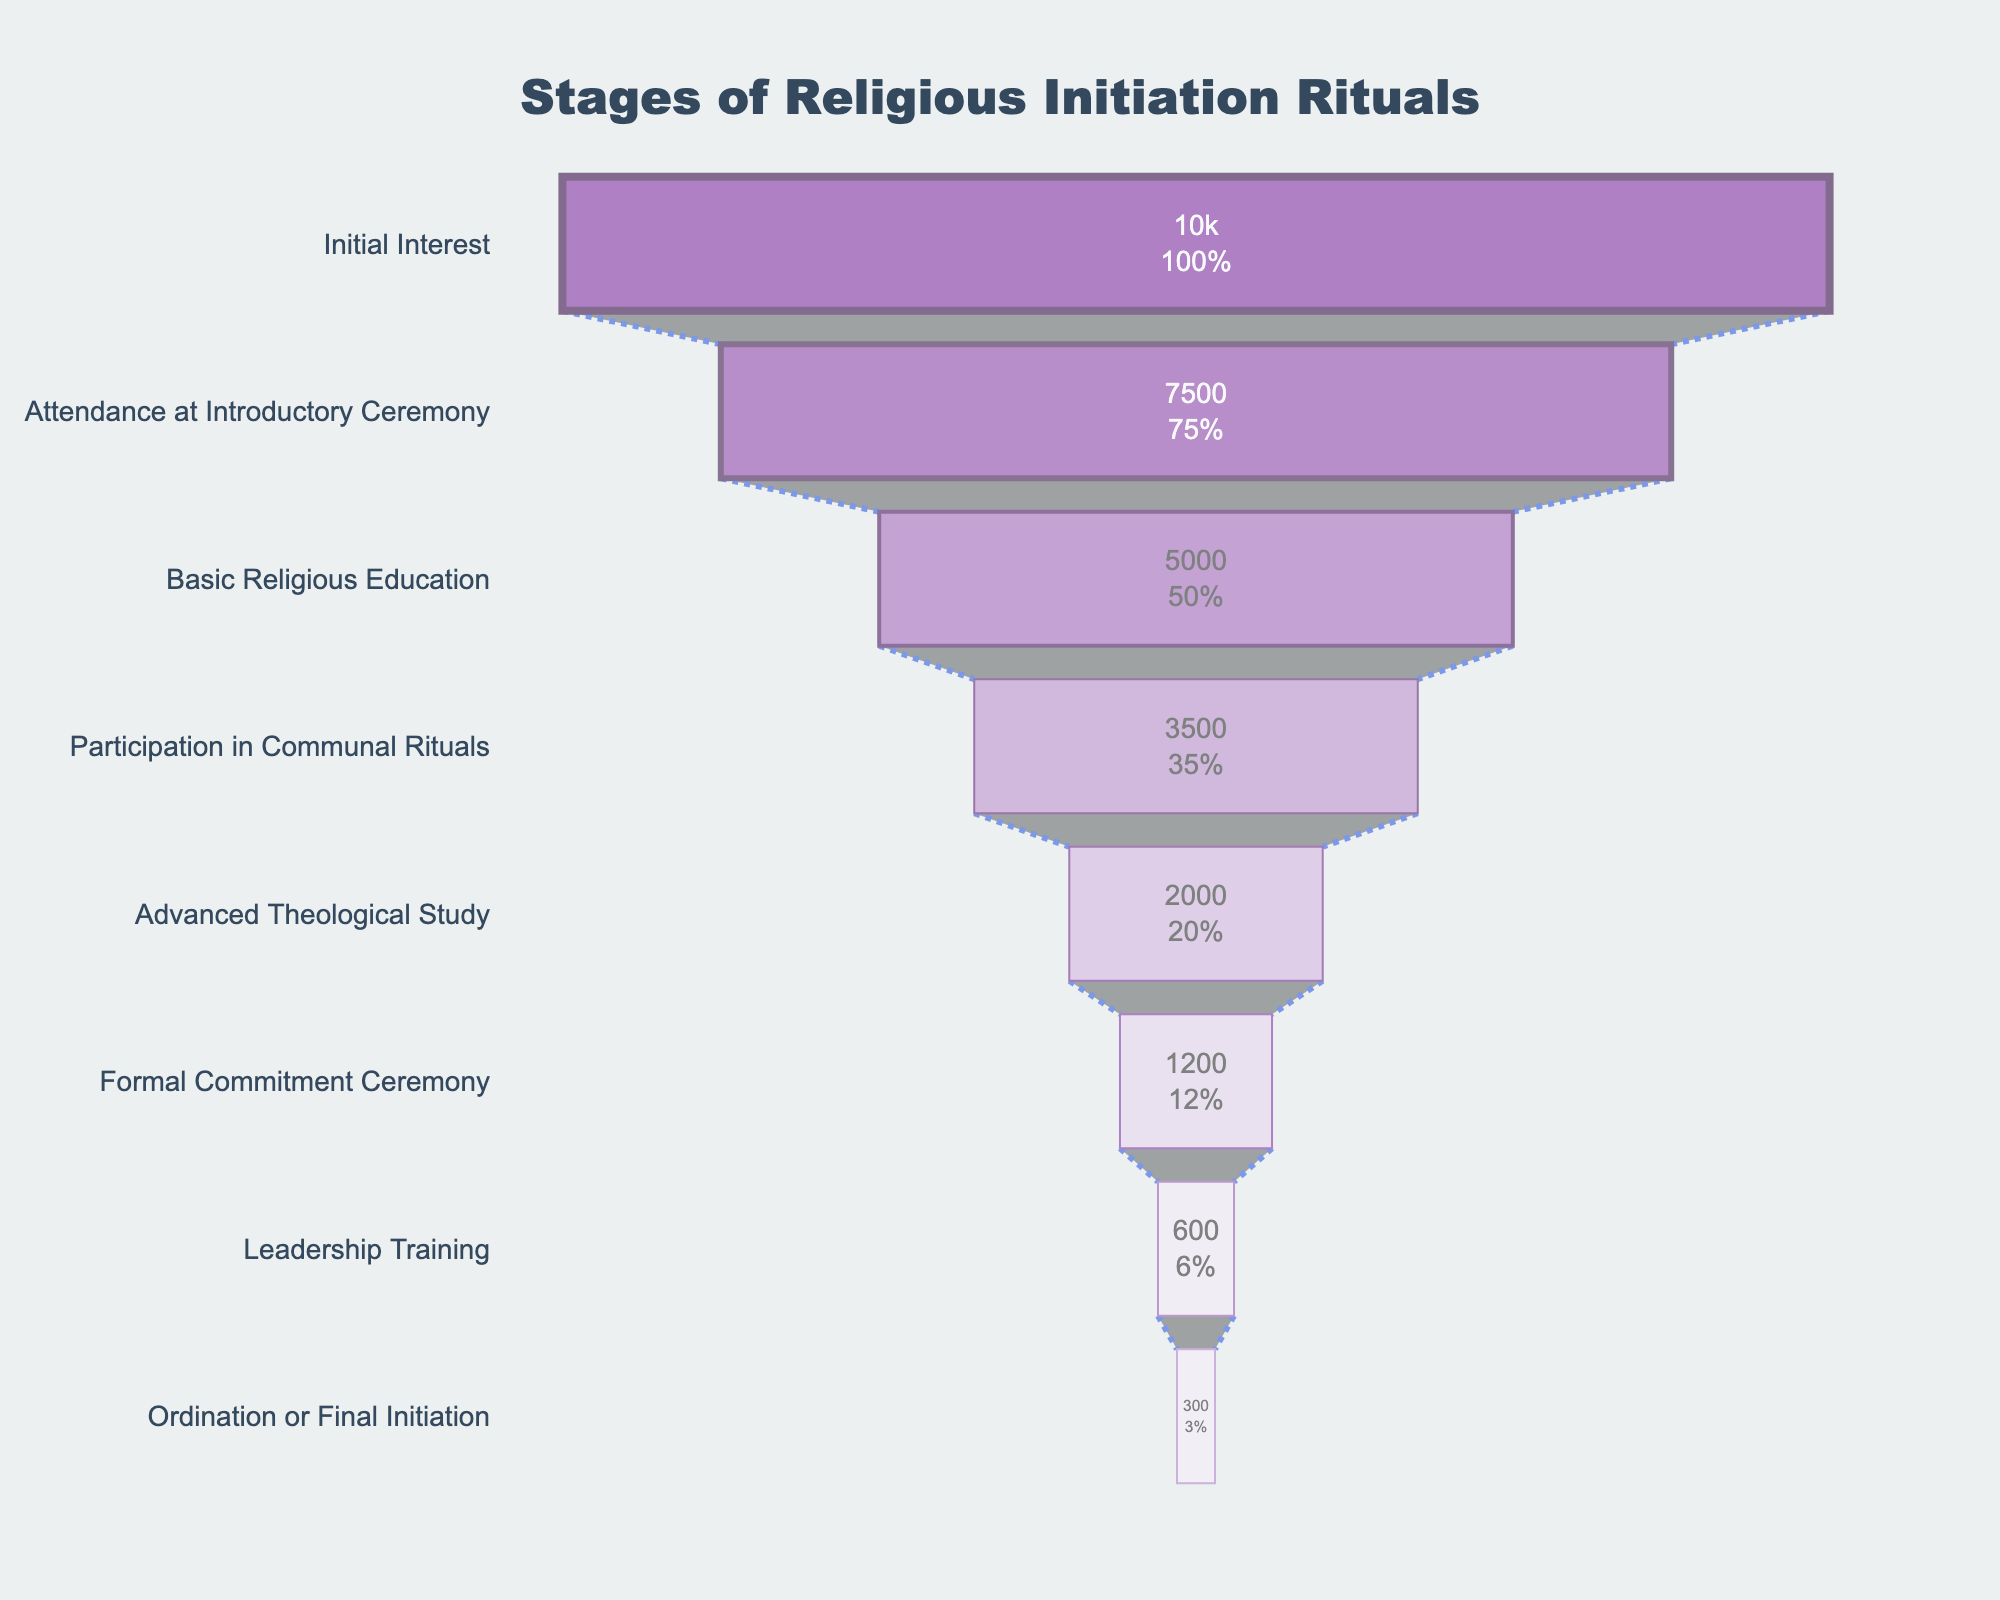What is the title of the funnel chart? The title of the funnel chart is always located at the top, centered. By looking at the top of the figure, one can read the title text.
Answer: Stages of Religious Initiation Rituals How many participants start with an initial interest? The funnel chart lists each stage along with the number of participants. At the top of the funnel, the number associated with "Initial Interest" is shown.
Answer: 10000 What percentage of participants engage in basic religious education compared to those who show initial interest? The chart provides percentages for each stage. For "Basic Religious Education," the percentage is shown on the bar starting from "Initial Interest."
Answer: 50% How many participants proceed from the Attendance at Introductory Ceremony to Basic Religious Education? Subtract the number of participants in "Basic Religious Education" from those in "Attendance at Introductory Ceremony": 7500 - 5000.
Answer: 2500 Which stage witnesses the highest dropout rate? By observing the drop in participant numbers from one stage to another, the highest dropout can be identified. The largest numerical gap between consecutive stages shows the highest dropout.
Answer: Initial Interest to Attendance at Introductory Ceremony How many participants complete the formal commitment ceremony? Look at the figure for the number associated with "Formal Commitment Ceremony" participants.
Answer: 1200 What is the ratio of participants in leadership training to those in advanced theological study? Divide the number of participants in "Leadership Training" by those in "Advanced Theological Study": 600 / 2000.
Answer: 0.3 Which stage involves the smallest number of participants? Locate the stage with the lowest number on the figure. This stage represents the smallest group.
Answer: Ordination or Final Initiation From Advanced Theological Study to Ordination or Final Initiation, how many participants discontinue? Subtract the number of participants in "Ordination or Final Initiation" from those in "Advanced Theological Study": 2000 - 300.
Answer: 1700 What is the predominant color used in the stage with the highest number of participants? The stage with the highest number of participants is "Initial Interest." Observe the predominant color used in that section of the chart.
Answer: Purple 